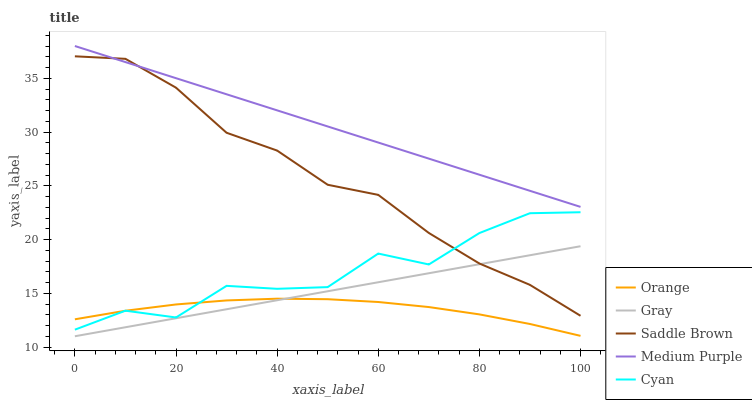Does Orange have the minimum area under the curve?
Answer yes or no. Yes. Does Medium Purple have the maximum area under the curve?
Answer yes or no. Yes. Does Gray have the minimum area under the curve?
Answer yes or no. No. Does Gray have the maximum area under the curve?
Answer yes or no. No. Is Medium Purple the smoothest?
Answer yes or no. Yes. Is Cyan the roughest?
Answer yes or no. Yes. Is Gray the smoothest?
Answer yes or no. No. Is Gray the roughest?
Answer yes or no. No. Does Gray have the lowest value?
Answer yes or no. Yes. Does Medium Purple have the lowest value?
Answer yes or no. No. Does Medium Purple have the highest value?
Answer yes or no. Yes. Does Gray have the highest value?
Answer yes or no. No. Is Cyan less than Medium Purple?
Answer yes or no. Yes. Is Saddle Brown greater than Orange?
Answer yes or no. Yes. Does Saddle Brown intersect Medium Purple?
Answer yes or no. Yes. Is Saddle Brown less than Medium Purple?
Answer yes or no. No. Is Saddle Brown greater than Medium Purple?
Answer yes or no. No. Does Cyan intersect Medium Purple?
Answer yes or no. No. 